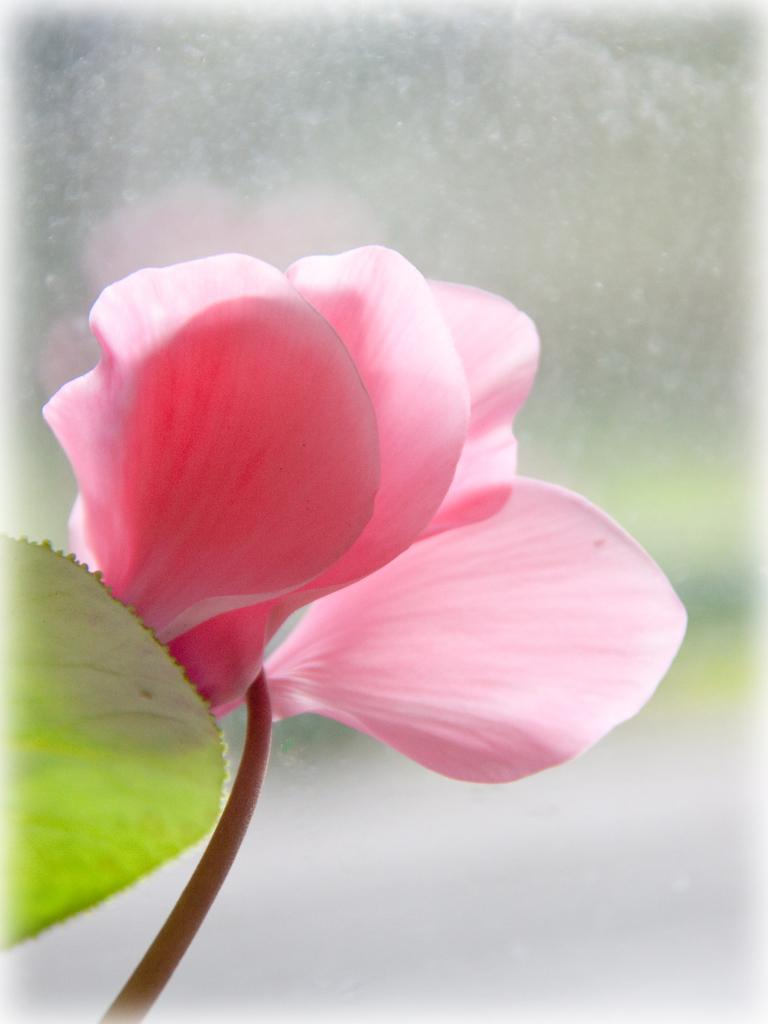What type of flower is present in the image? There is a pink flower in the image. Can you describe the background of the image? The background of the image is blurry. What type of wax can be seen melting in the image? There is no wax present in the image. Is there a friend visible in the image? There is no friend visible in the image; it only features a pink flower and a blurry background. 